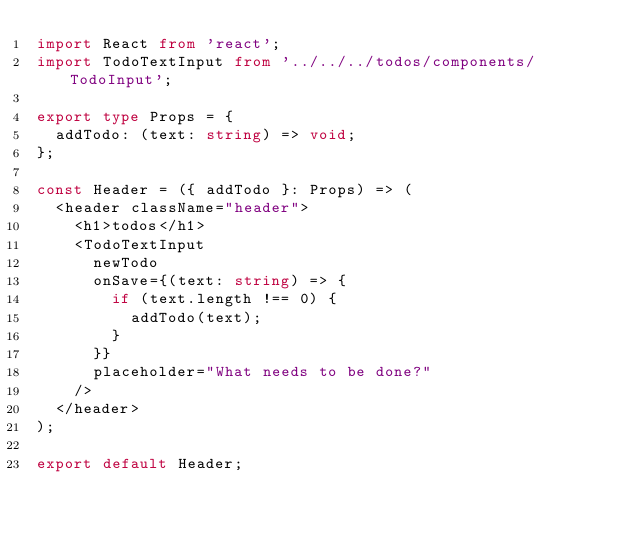Convert code to text. <code><loc_0><loc_0><loc_500><loc_500><_TypeScript_>import React from 'react';
import TodoTextInput from '../../../todos/components/TodoInput';

export type Props = {
  addTodo: (text: string) => void;
};

const Header = ({ addTodo }: Props) => (
  <header className="header">
    <h1>todos</h1>
    <TodoTextInput
      newTodo
      onSave={(text: string) => {
        if (text.length !== 0) {
          addTodo(text);
        }
      }}
      placeholder="What needs to be done?"
    />
  </header>
);

export default Header;
</code> 